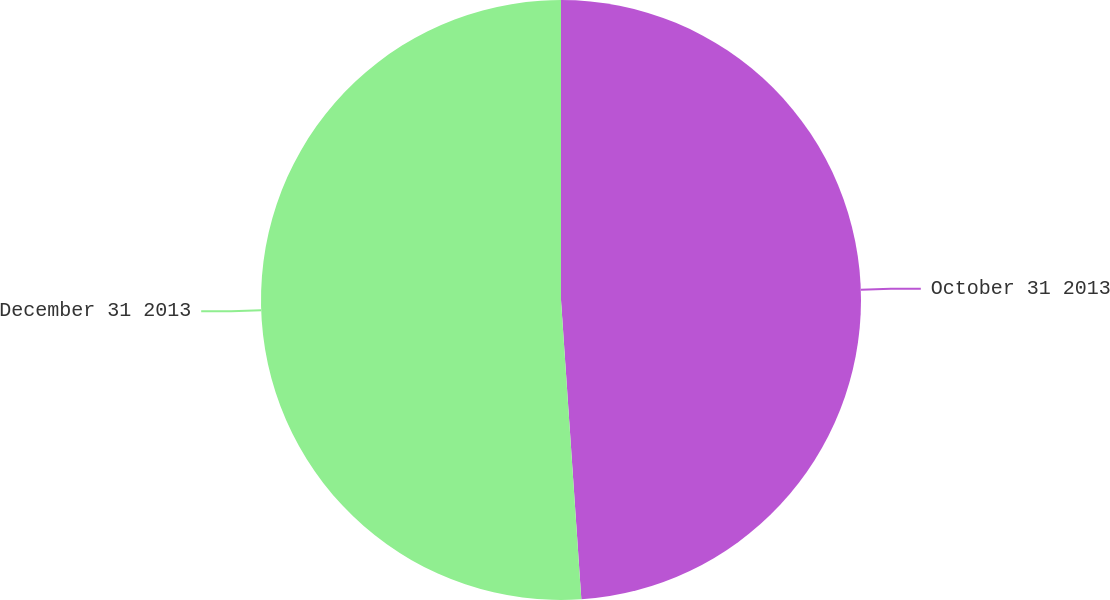Convert chart. <chart><loc_0><loc_0><loc_500><loc_500><pie_chart><fcel>October 31 2013<fcel>December 31 2013<nl><fcel>48.92%<fcel>51.08%<nl></chart> 